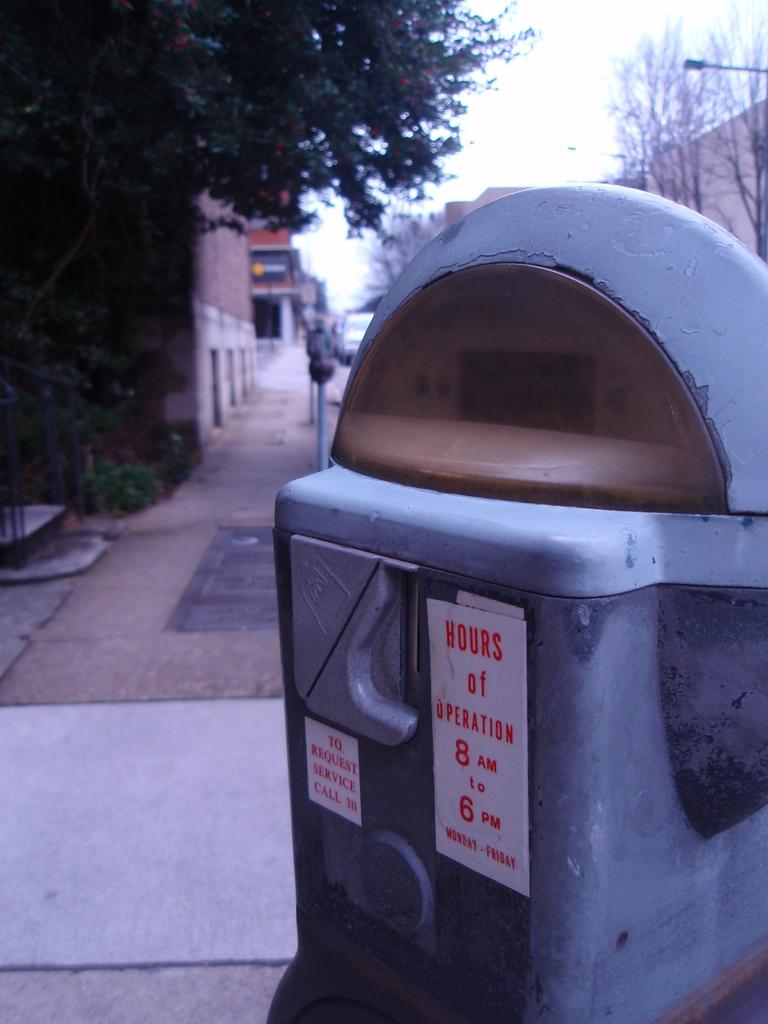<image>
Present a compact description of the photo's key features. A parking meter with the words Hours of Operation 8am to 6pm on it. 